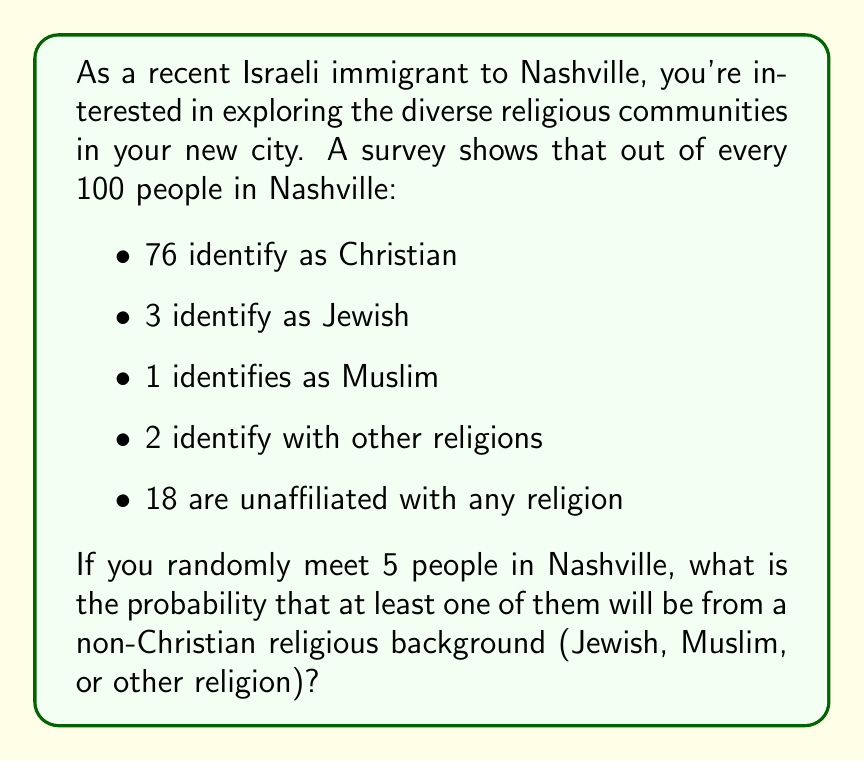Can you answer this question? To solve this problem, we'll use the complement rule of probability. Instead of calculating the probability of meeting at least one person from a non-Christian religious background, we'll calculate the probability of not meeting any, and then subtract that from 1.

1. First, let's calculate the probability of meeting someone who is not from a non-Christian religious background (i.e., either Christian or unaffiliated):

   $P(\text{Christian or unaffiliated}) = \frac{76 + 18}{100} = 0.94$

2. The probability of meeting 5 people who are all either Christian or unaffiliated is:

   $P(\text{all 5 Christian or unaffiliated}) = 0.94^5 = 0.7339$

3. Therefore, the probability of meeting at least one person from a non-Christian religious background is:

   $P(\text{at least one non-Christian religious}) = 1 - P(\text{all 5 Christian or unaffiliated})$
   
   $= 1 - 0.7339 = 0.2661$

This can also be expressed as a percentage: $0.2661 \times 100\% = 26.61\%$
Answer: The probability of meeting at least one person from a non-Christian religious background when randomly encountering 5 people in Nashville is approximately 0.2661 or 26.61%. 